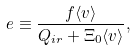<formula> <loc_0><loc_0><loc_500><loc_500>e \equiv \frac { f \langle v \rangle } { Q _ { i r } + \Xi _ { 0 } \langle v \rangle } ,</formula> 